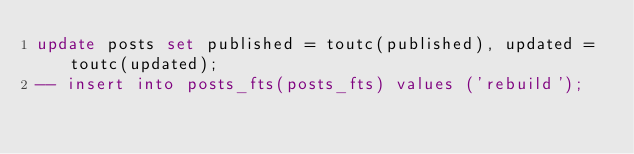<code> <loc_0><loc_0><loc_500><loc_500><_SQL_>update posts set published = toutc(published), updated = toutc(updated);
-- insert into posts_fts(posts_fts) values ('rebuild');</code> 